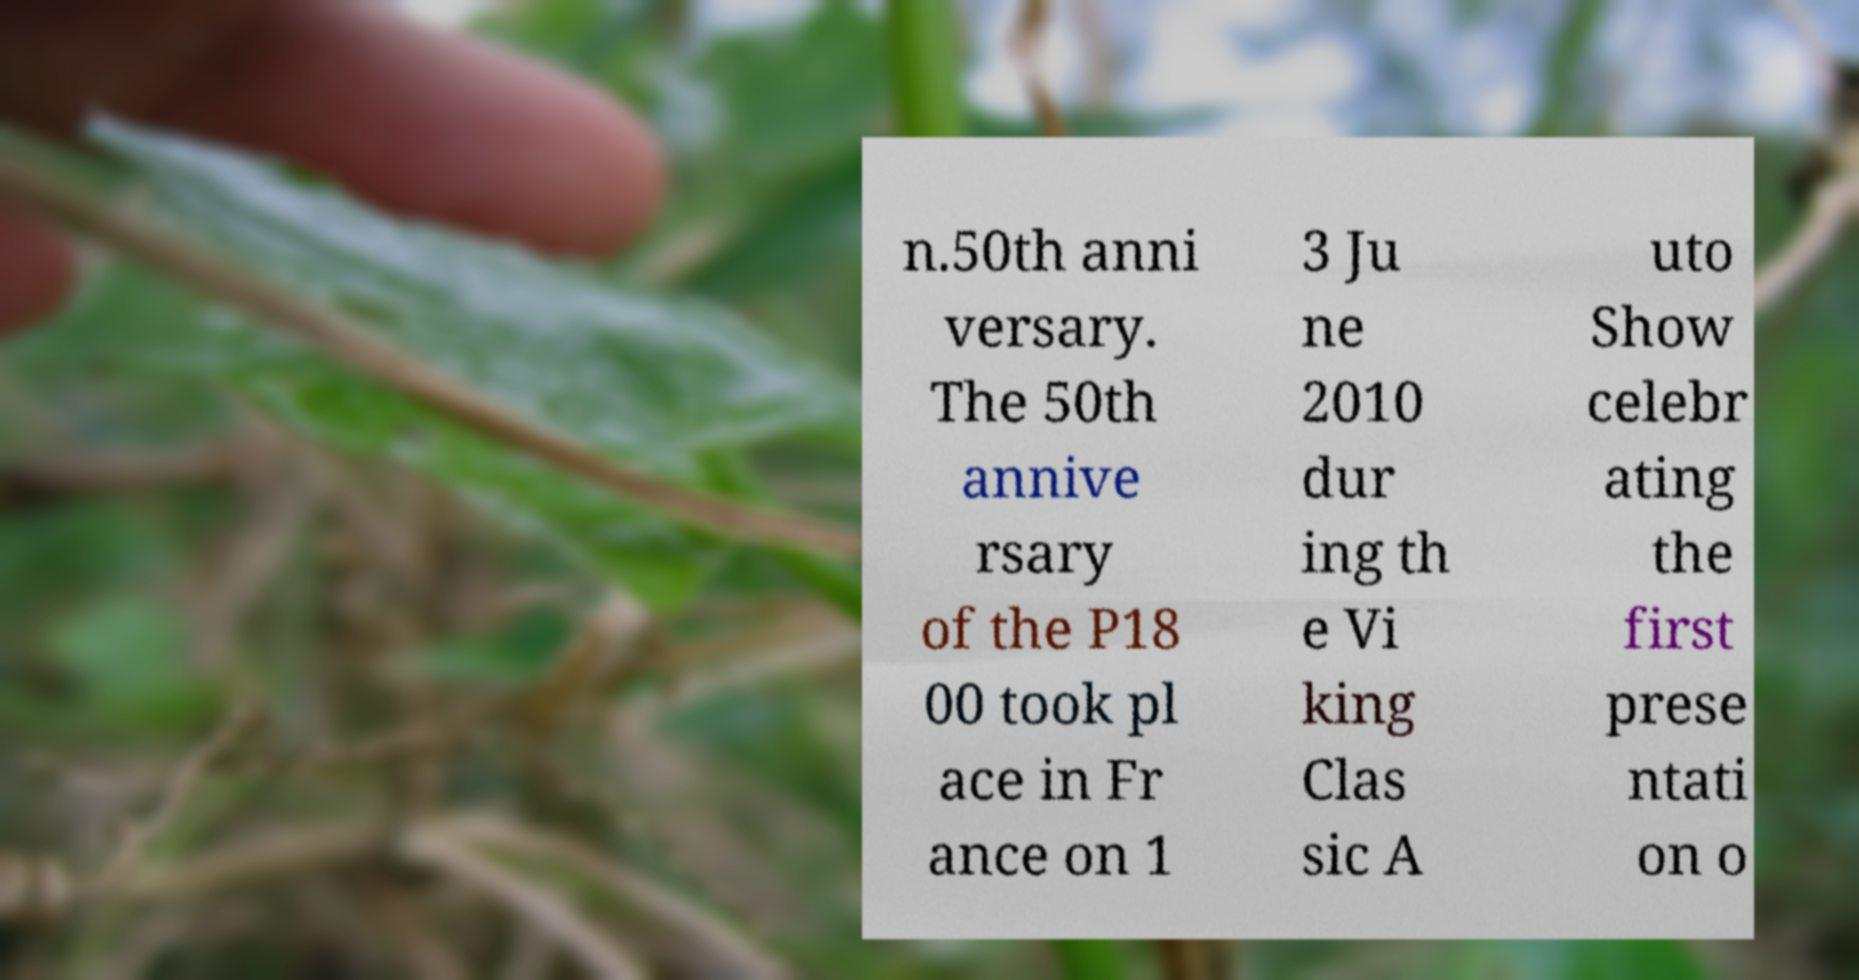I need the written content from this picture converted into text. Can you do that? n.50th anni versary. The 50th annive rsary of the P18 00 took pl ace in Fr ance on 1 3 Ju ne 2010 dur ing th e Vi king Clas sic A uto Show celebr ating the first prese ntati on o 